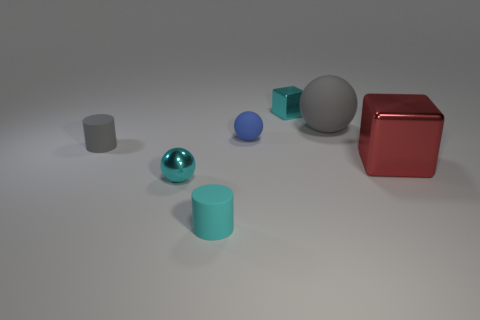Add 1 big gray rubber spheres. How many objects exist? 8 Subtract all blocks. How many objects are left? 5 Add 7 small balls. How many small balls are left? 9 Add 1 tiny cylinders. How many tiny cylinders exist? 3 Subtract 0 green blocks. How many objects are left? 7 Subtract all tiny cubes. Subtract all tiny cyan metallic blocks. How many objects are left? 5 